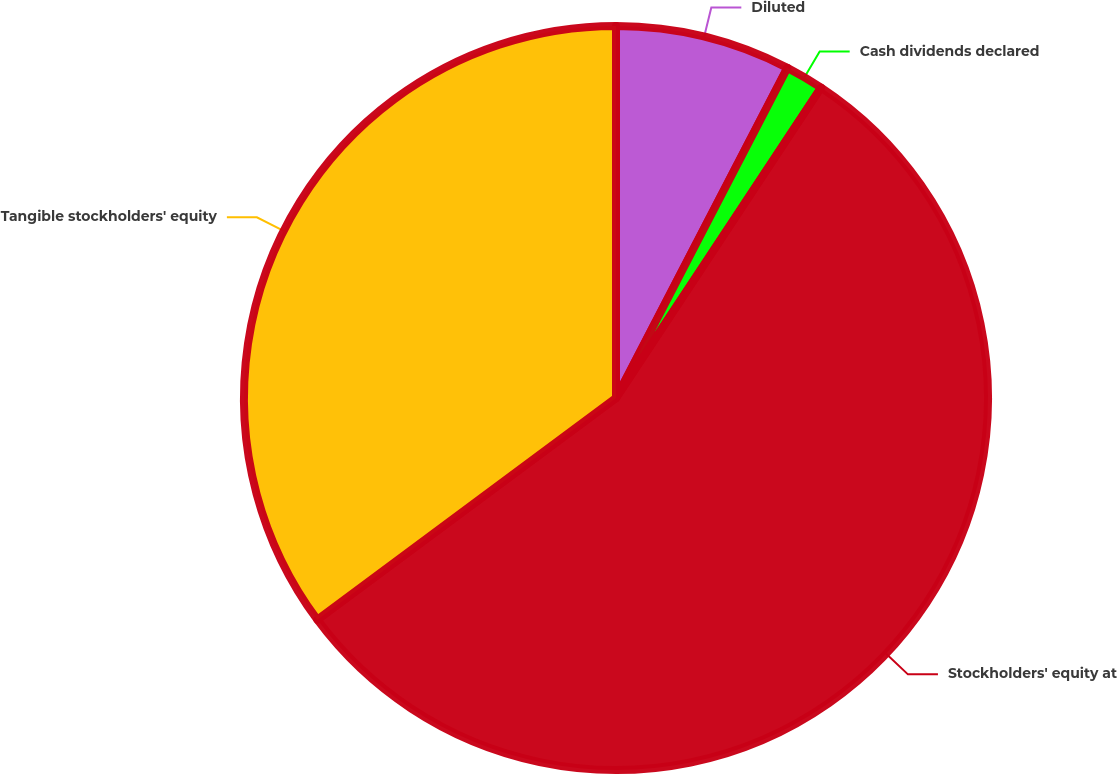Convert chart. <chart><loc_0><loc_0><loc_500><loc_500><pie_chart><fcel>Diluted<fcel>Cash dividends declared<fcel>Stockholders' equity at<fcel>Tangible stockholders' equity<nl><fcel>7.62%<fcel>1.67%<fcel>55.54%<fcel>35.16%<nl></chart> 